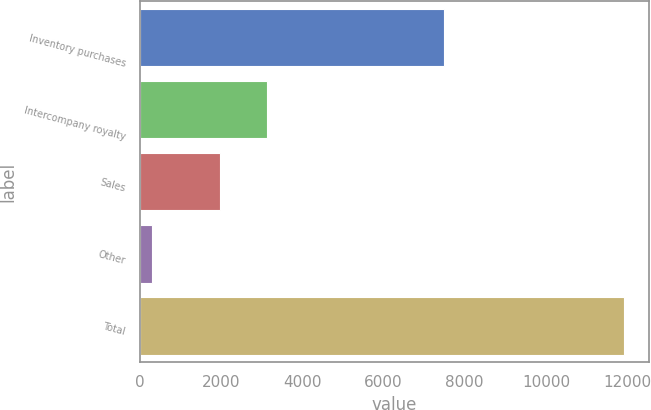Convert chart to OTSL. <chart><loc_0><loc_0><loc_500><loc_500><bar_chart><fcel>Inventory purchases<fcel>Intercompany royalty<fcel>Sales<fcel>Other<fcel>Total<nl><fcel>7493<fcel>3127.8<fcel>1965<fcel>302<fcel>11930<nl></chart> 